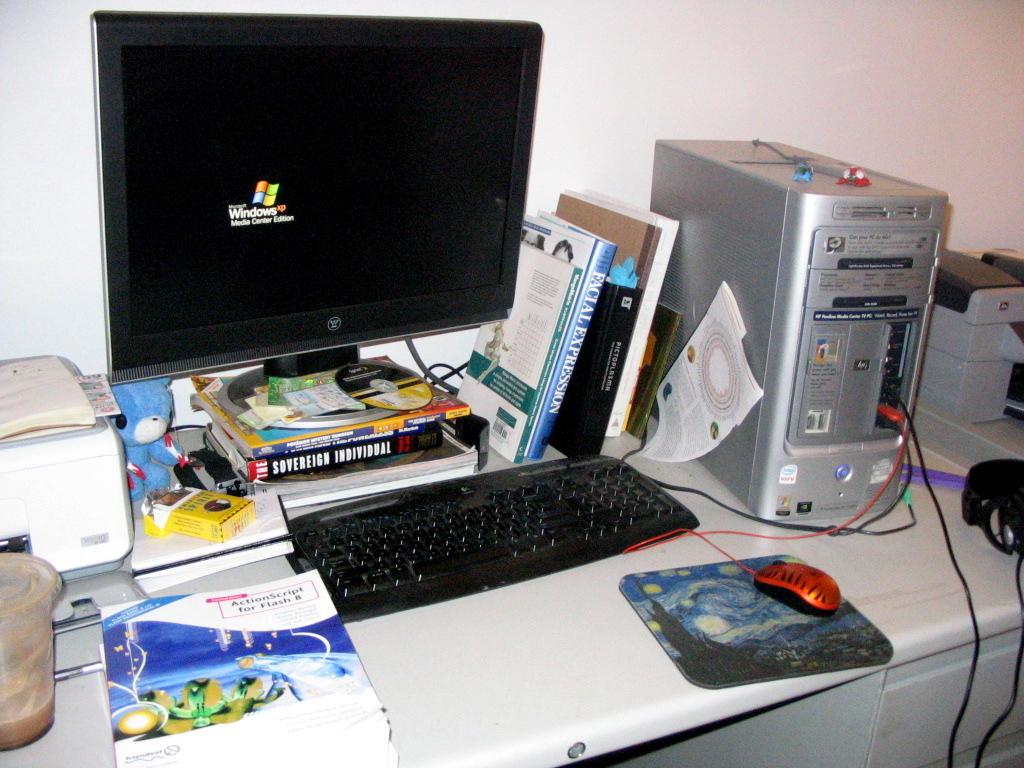What operating system is the computer?
Provide a succinct answer. Windows xp. What actionscript does the book discuss?
Give a very brief answer. Flash 8. 